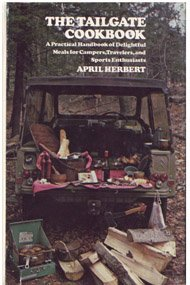Is this book related to Romance? No, this book does not delve into romance. It is strictly a cookbook focusing on culinary delights for social gatherings outdoors, like tailgating. 